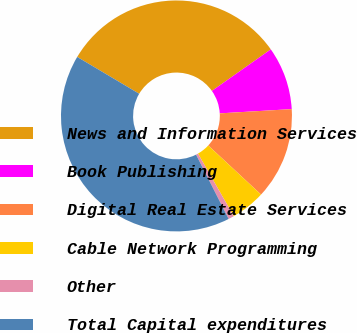<chart> <loc_0><loc_0><loc_500><loc_500><pie_chart><fcel>News and Information Services<fcel>Book Publishing<fcel>Digital Real Estate Services<fcel>Cable Network Programming<fcel>Other<fcel>Total Capital expenditures<nl><fcel>31.68%<fcel>8.84%<fcel>12.86%<fcel>4.82%<fcel>0.8%<fcel>41.0%<nl></chart> 